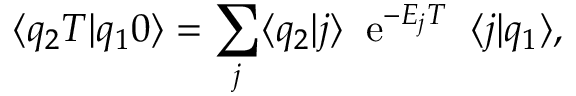Convert formula to latex. <formula><loc_0><loc_0><loc_500><loc_500>\langle q _ { 2 } T | q _ { 1 } 0 \rangle = \sum _ { j } \langle q _ { 2 } | j \rangle \, e ^ { - E _ { j } T } \, \langle j | q _ { 1 } \rangle ,</formula> 